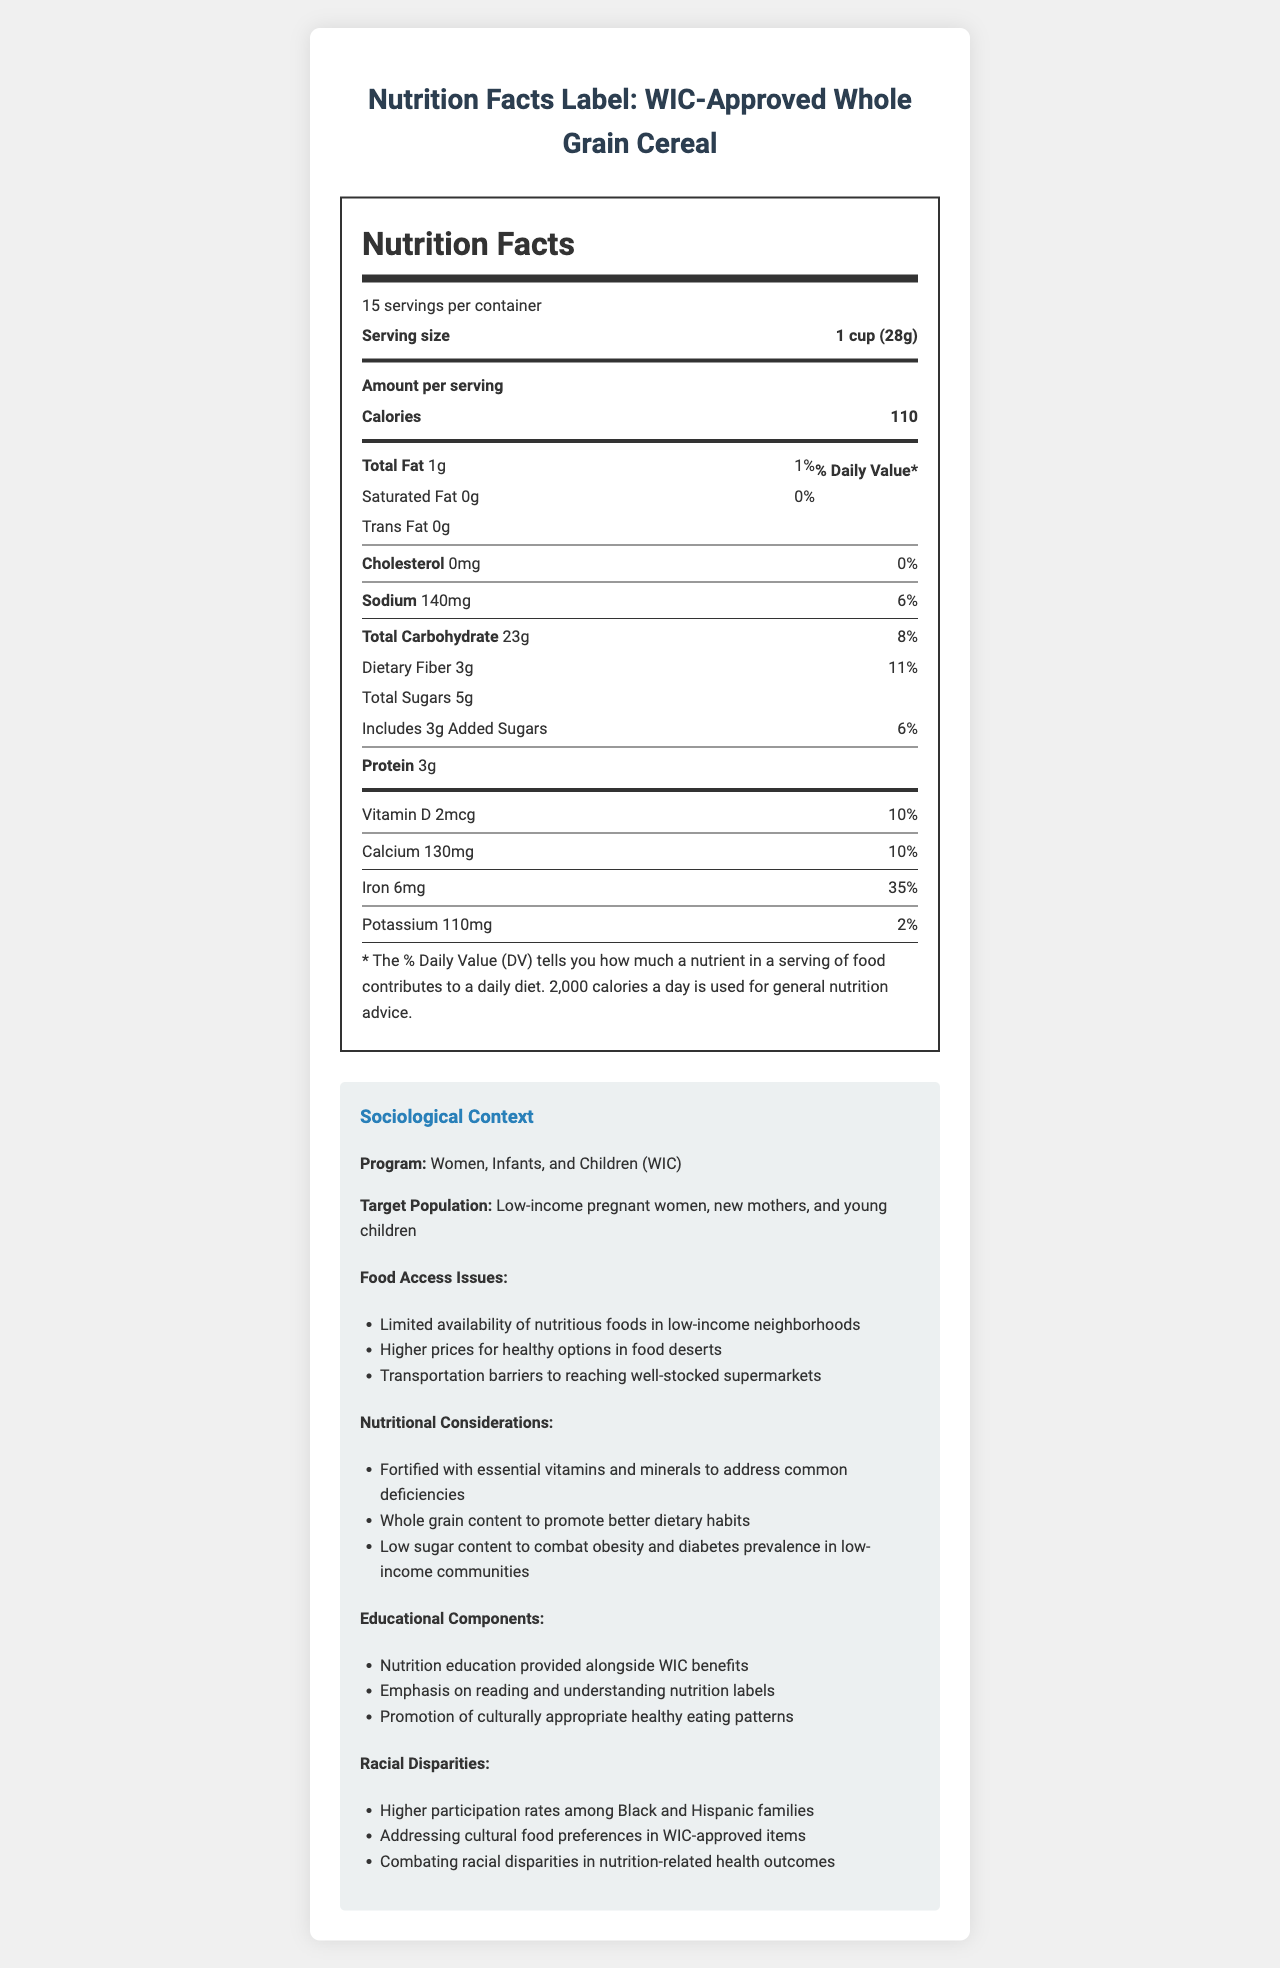how many calories are in one serving of the cereal? The document states that there are 110 calories per serving.
Answer: 110 how much dietary fiber does one serving provide? According to the nutrition label, one serving contains 3 grams of dietary fiber.
Answer: 3g what is the target population for the WIC program? The sociological context section specifies this target population.
Answer: Low-income pregnant women, new mothers, and young children how much iron does the cereal provide per serving? The nutrition label shows that each serving contains 6mg of iron.
Answer: 6mg what percentage of the daily value of calcium is provided in one serving? The document indicates that one serving of the cereal provides 10% of the daily value of calcium.
Answer: 10% how much-added sugars are in one serving of the cereal? According to the nutrition label, each serving includes 3 grams of added sugars.
Answer: 3g does the cereal contain any saturated fat? A. Yes B. No The document shows that the cereal contains 0 grams of saturated fat.
Answer: B. No which of the following is a food access issue mentioned? I. Limited availability of nutritious foods in low-income neighborhoods II. High demand for luxury foods III. Vitamin supplements are widely available The food access issues listed include "Limited availability of nutritious foods in low-income neighborhoods."
Answer: I is the program WIC focused on high-income families? The target population described is low-income pregnant women, new mothers, and young children.
Answer: No summarize the main points of the document. This comprehensive summary includes the key elements presented in the document.
Answer: The document presents the nutrition facts label for a WIC-approved whole grain cereal, highlighting its nutritional content, target population, food access issues, nutritional considerations, educational components, and racial disparities. Key highlights include the cereal's iron, dietary fiber, and low sugar content, important for addressing dietary needs in low-income communities. how does the cereal's sodium content relate to the daily value percentage? The document shows that the sodium content per serving is 140mg, which is 6% of the daily value.
Answer: 140mg, 6% how are the racial disparities addressed in the WIC program? According to the sociological context section, these are among the measures taken to address racial disparities.
Answer: Addressing cultural food preferences in WIC-approved items and combating racial disparities in nutrition-related health outcomes what is the exact price of the cereal? The document does not provide information about the price of the cereal.
Answer: Not enough information 